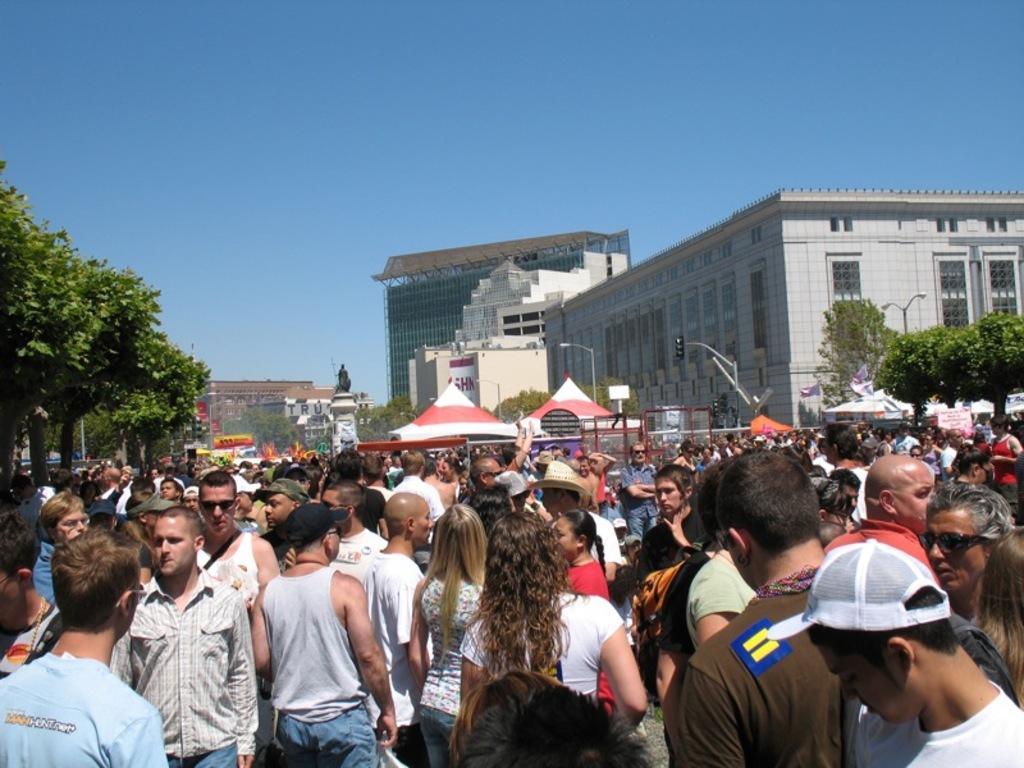In one or two sentences, can you explain what this image depicts? In this picture there are people and we can see trees, sculpture on the platform, poles, lights, traffic signal, buildings and boards. In the background of the image we can see the sky. 